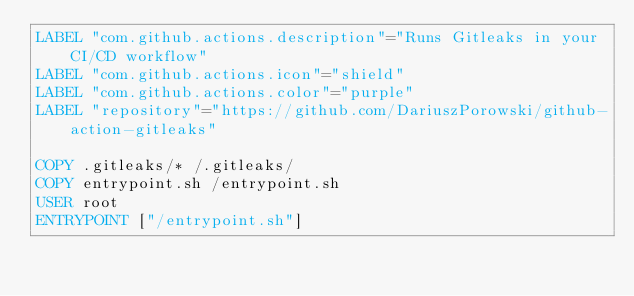<code> <loc_0><loc_0><loc_500><loc_500><_Dockerfile_>LABEL "com.github.actions.description"="Runs Gitleaks in your CI/CD workflow"
LABEL "com.github.actions.icon"="shield"
LABEL "com.github.actions.color"="purple"
LABEL "repository"="https://github.com/DariuszPorowski/github-action-gitleaks"

COPY .gitleaks/* /.gitleaks/
COPY entrypoint.sh /entrypoint.sh
USER root
ENTRYPOINT ["/entrypoint.sh"]</code> 